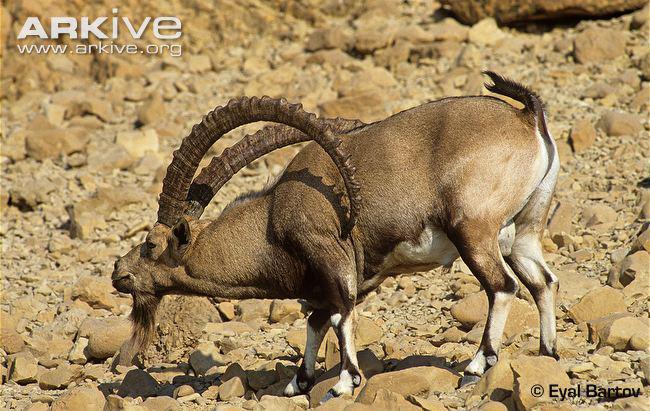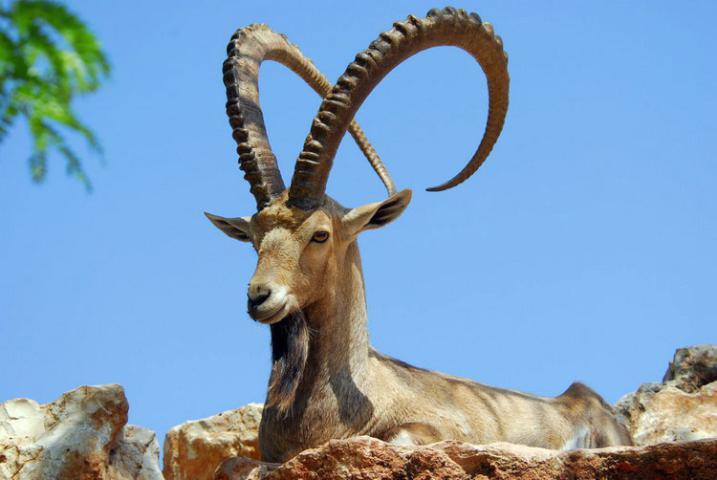The first image is the image on the left, the second image is the image on the right. Evaluate the accuracy of this statement regarding the images: "The left and right image contains three horned goats.". Is it true? Answer yes or no. No. The first image is the image on the left, the second image is the image on the right. Assess this claim about the two images: "In one of the images, the heads of two goats are visible.". Correct or not? Answer yes or no. No. 